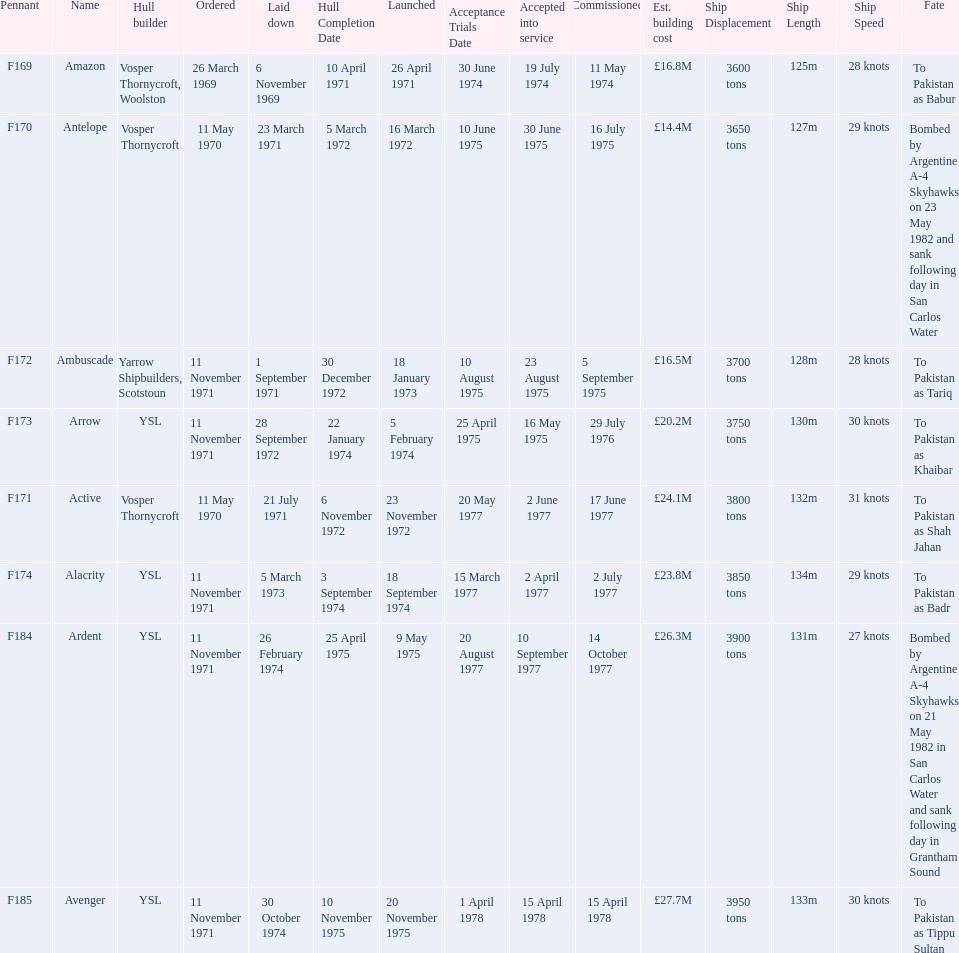How many ships were built after ardent? 1. Write the full table. {'header': ['Pennant', 'Name', 'Hull builder', 'Ordered', 'Laid down', 'Hull Completion Date', 'Launched', 'Acceptance Trials Date', 'Accepted into service', 'Commissioned', 'Est. building cost', 'Ship Displacement', 'Ship Length', 'Ship Speed', 'Fate'], 'rows': [['F169', 'Amazon', 'Vosper Thornycroft, Woolston', '26 March 1969', '6 November 1969', '10 April 1971', '26 April 1971', '30 June 1974', '19 July 1974', '11 May 1974', '£16.8M', '3600 tons', '125m', '28 knots', 'To Pakistan as Babur'], ['F170', 'Antelope', 'Vosper Thornycroft', '11 May 1970', '23 March 1971', '5 March 1972', '16 March 1972', '10 June 1975', '30 June 1975', '16 July 1975', '£14.4M', '3650 tons', '127m', '29 knots', 'Bombed by Argentine A-4 Skyhawks on 23 May 1982 and sank following day in San Carlos Water'], ['F172', 'Ambuscade', 'Yarrow Shipbuilders, Scotstoun', '11 November 1971', '1 September 1971', '30 December 1972', '18 January 1973', '10 August 1975', '23 August 1975', '5 September 1975', '£16.5M', '3700 tons', '128m', '28 knots', 'To Pakistan as Tariq'], ['F173', 'Arrow', 'YSL', '11 November 1971', '28 September 1972', '22 January 1974', '5 February 1974', '25 April 1975', '16 May 1975', '29 July 1976', '£20.2M', '3750 tons', '130m', '30 knots', 'To Pakistan as Khaibar'], ['F171', 'Active', 'Vosper Thornycroft', '11 May 1970', '21 July 1971', '6 November 1972', '23 November 1972', '20 May 1977', '2 June 1977', '17 June 1977', '£24.1M', '3800 tons', '132m', '31 knots', 'To Pakistan as Shah Jahan'], ['F174', 'Alacrity', 'YSL', '11 November 1971', '5 March 1973', '3 September 1974', '18 September 1974', '15 March 1977', '2 April 1977', '2 July 1977', '£23.8M', '3850 tons', '134m', '29 knots', 'To Pakistan as Badr'], ['F184', 'Ardent', 'YSL', '11 November 1971', '26 February 1974', '25 April 1975', '9 May 1975', '20 August 1977', '10 September 1977', '14 October 1977', '£26.3M', '3900 tons', '131m', '27 knots', 'Bombed by Argentine A-4 Skyhawks on 21 May 1982 in San Carlos Water and sank following day in Grantham Sound'], ['F185', 'Avenger', 'YSL', '11 November 1971', '30 October 1974', '10 November 1975', '20 November 1975', '1 April 1978', '15 April 1978', '15 April 1978', '£27.7M', '3950 tons', '133m', '30 knots', 'To Pakistan as Tippu Sultan']]} 